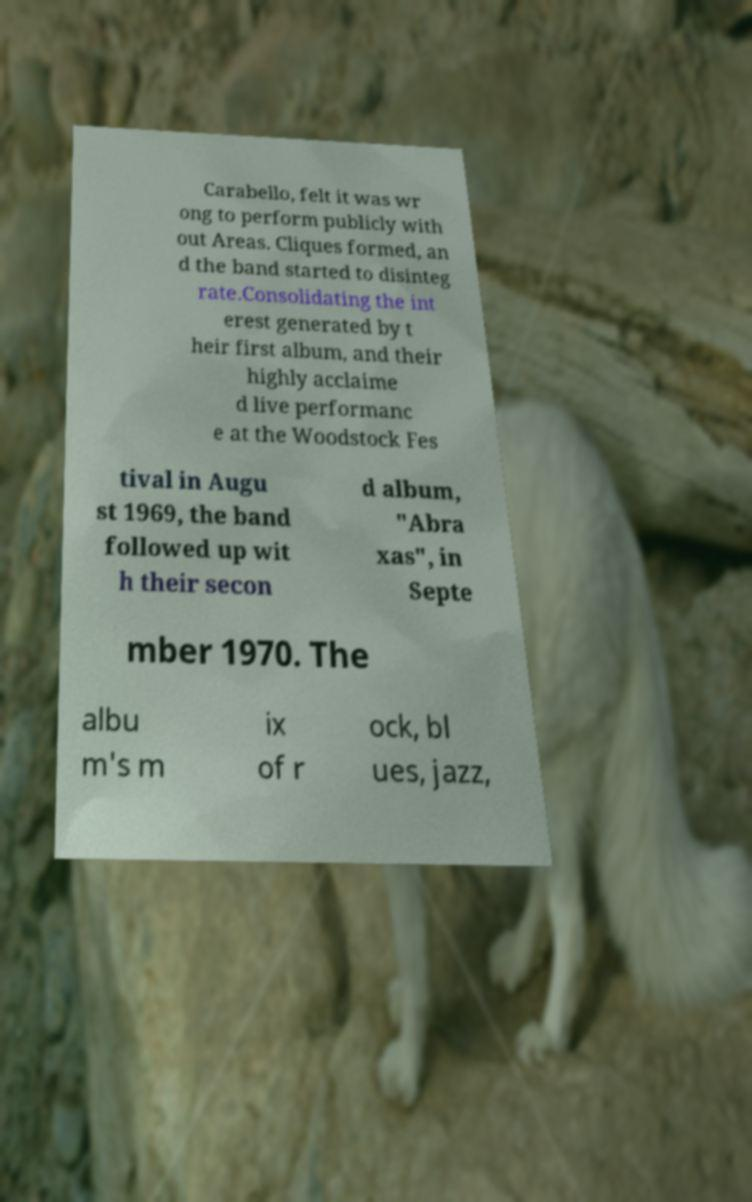Can you read and provide the text displayed in the image?This photo seems to have some interesting text. Can you extract and type it out for me? Carabello, felt it was wr ong to perform publicly with out Areas. Cliques formed, an d the band started to disinteg rate.Consolidating the int erest generated by t heir first album, and their highly acclaime d live performanc e at the Woodstock Fes tival in Augu st 1969, the band followed up wit h their secon d album, "Abra xas", in Septe mber 1970. The albu m's m ix of r ock, bl ues, jazz, 